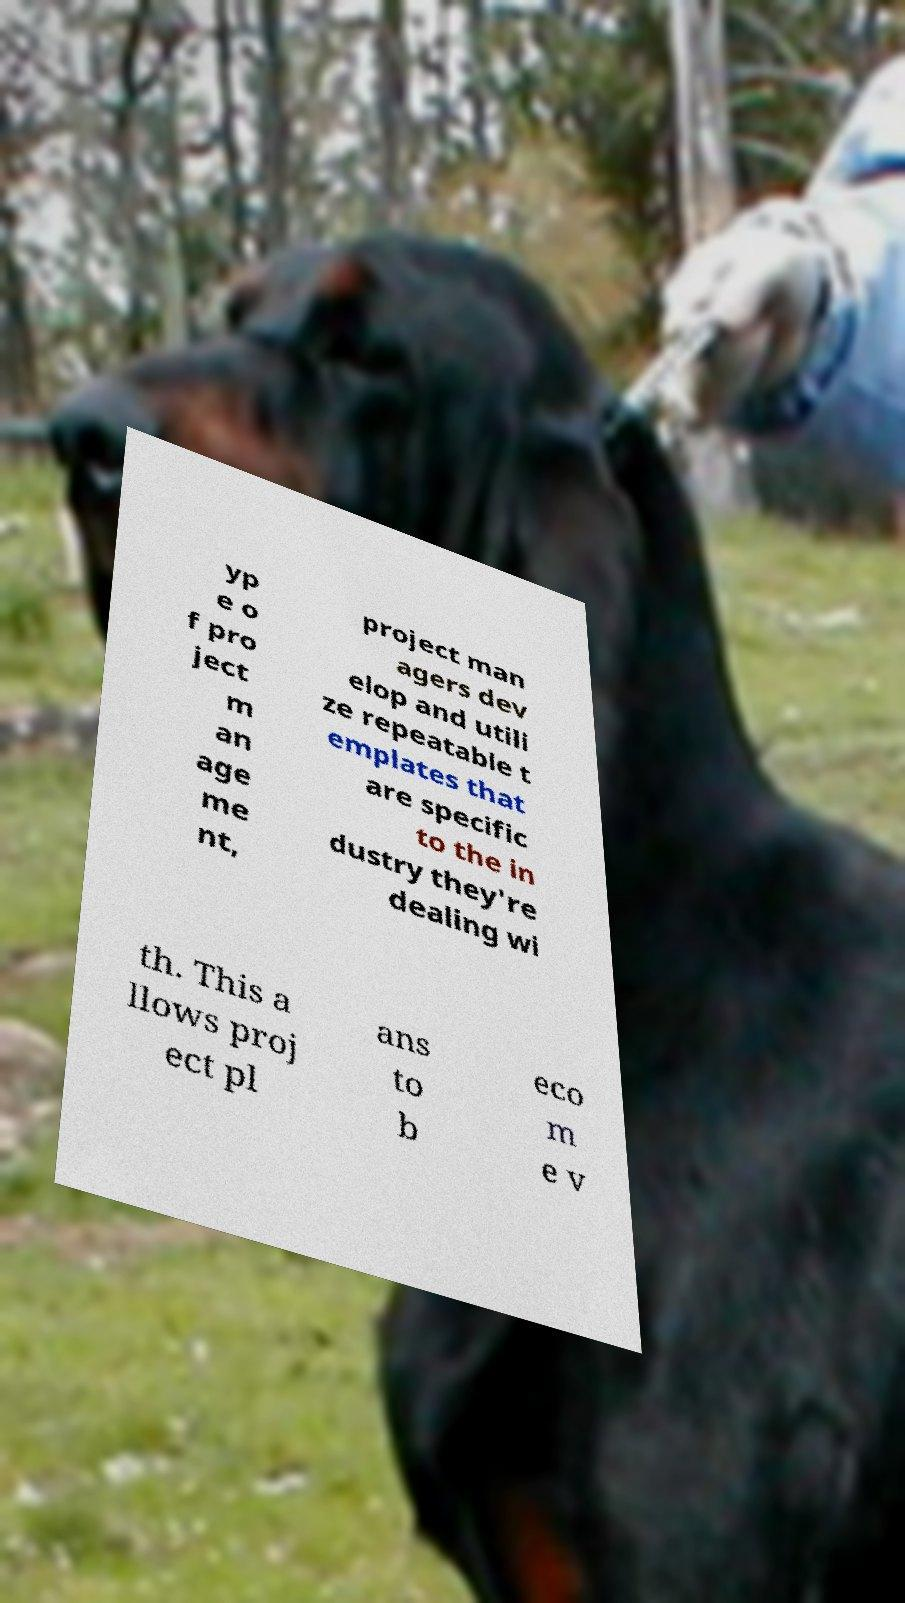There's text embedded in this image that I need extracted. Can you transcribe it verbatim? yp e o f pro ject m an age me nt, project man agers dev elop and utili ze repeatable t emplates that are specific to the in dustry they're dealing wi th. This a llows proj ect pl ans to b eco m e v 